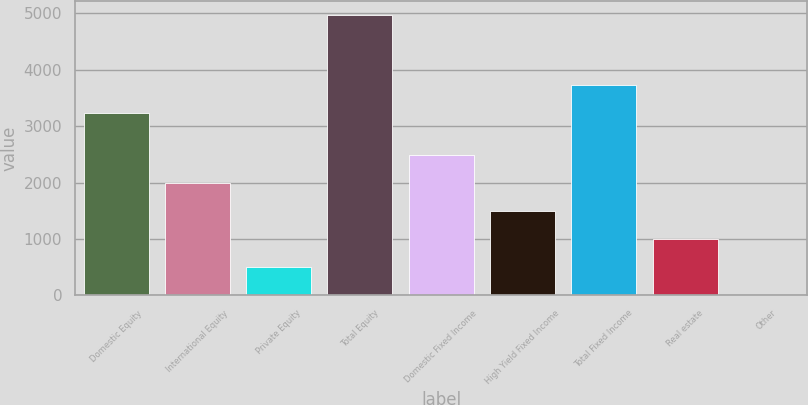Convert chart. <chart><loc_0><loc_0><loc_500><loc_500><bar_chart><fcel>Domestic Equity<fcel>International Equity<fcel>Private Equity<fcel>Total Equity<fcel>Domestic Fixed Income<fcel>High Yield Fixed Income<fcel>Total Fixed Income<fcel>Real estate<fcel>Other<nl><fcel>3238<fcel>1990.6<fcel>501.4<fcel>4969<fcel>2487<fcel>1494.2<fcel>3734.4<fcel>997.8<fcel>5<nl></chart> 